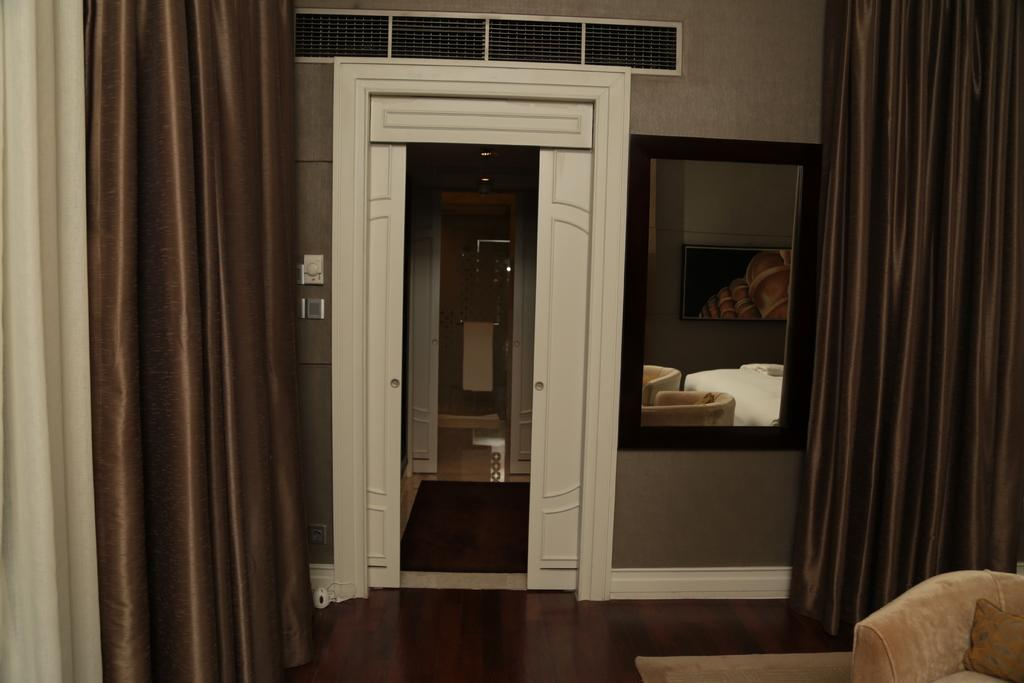How many doors can be seen in the image? There are two doors in the image. What type of window treatment is present in the image? There are curtains in the image. What type of seating is visible in the image? There is a sofa in the image. What type of fabric is present in the image? There is a towel in the image. What type of floor covering is present in the image? There is a floor mat in the image. What type of reflective surface is present in the image? There is a mirror in the image. What type of liquid can be seen dripping from the fang in the image? There is no fang or liquid present in the image. What type of medical facility is depicted in the image? The image does not depict a hospital or any medical facility. 